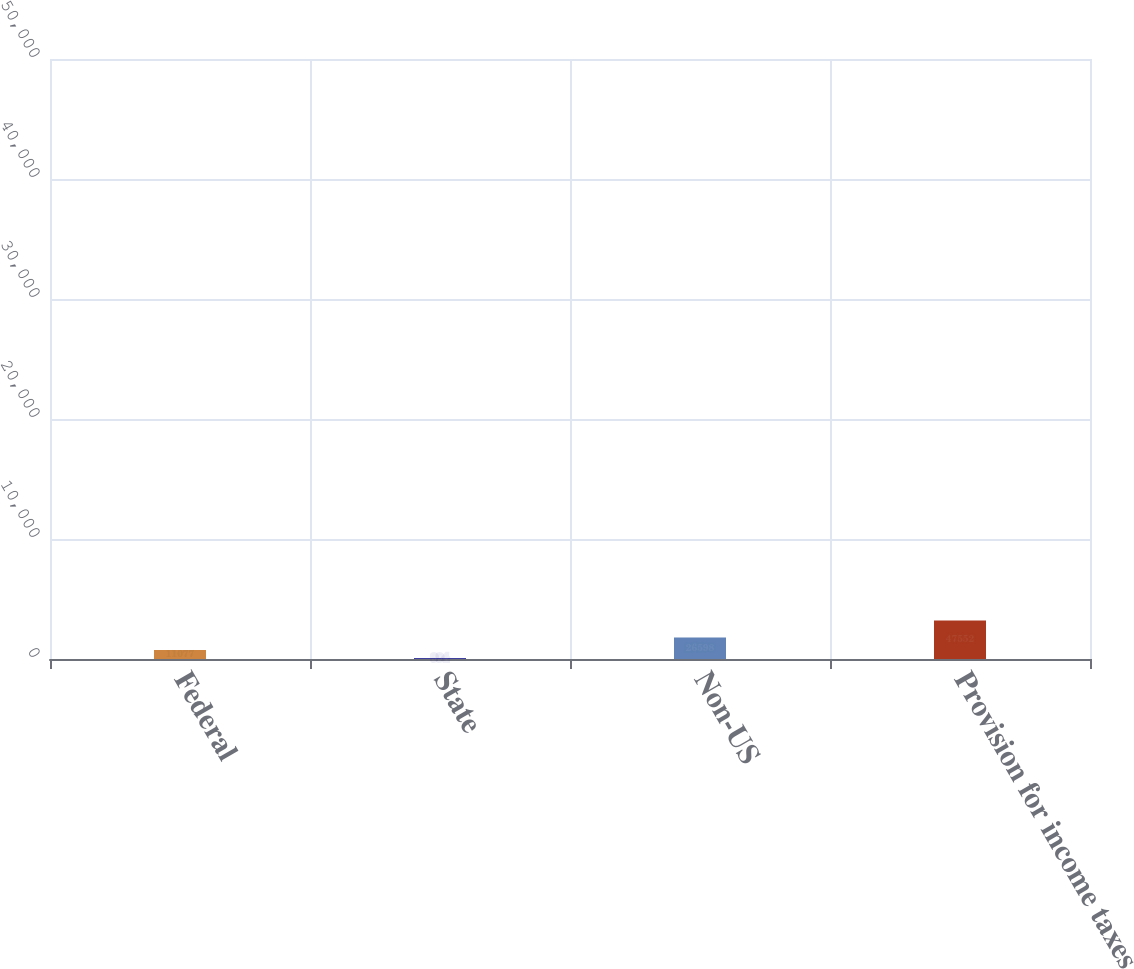Convert chart. <chart><loc_0><loc_0><loc_500><loc_500><bar_chart><fcel>Federal<fcel>State<fcel>Non-US<fcel>Provision for income taxes<nl><fcel>11077<fcel>994<fcel>26598<fcel>47552<nl></chart> 